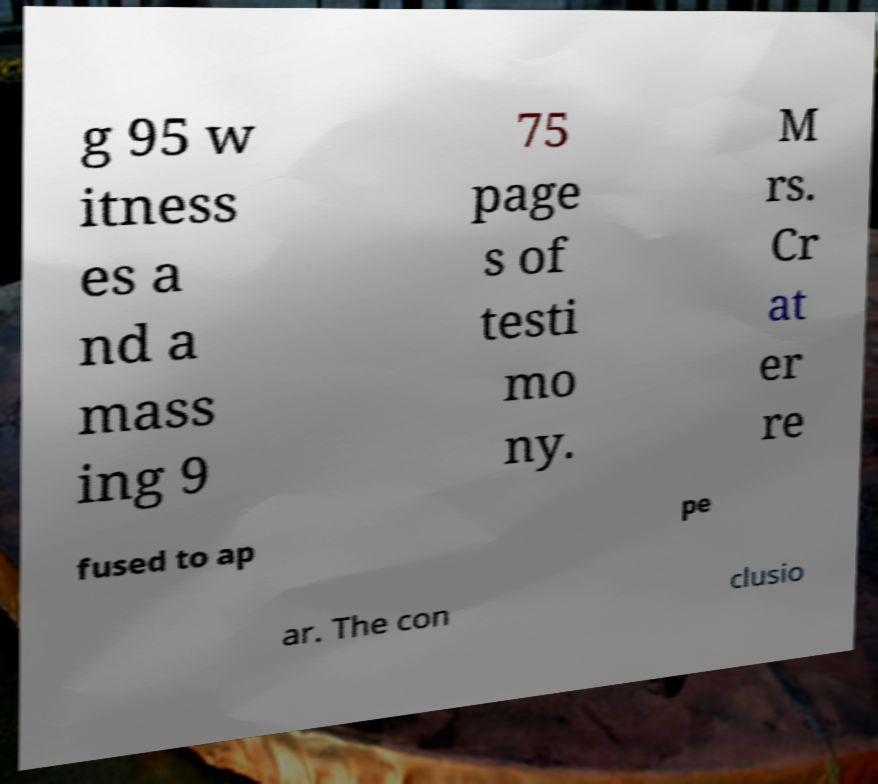There's text embedded in this image that I need extracted. Can you transcribe it verbatim? g 95 w itness es a nd a mass ing 9 75 page s of testi mo ny. M rs. Cr at er re fused to ap pe ar. The con clusio 